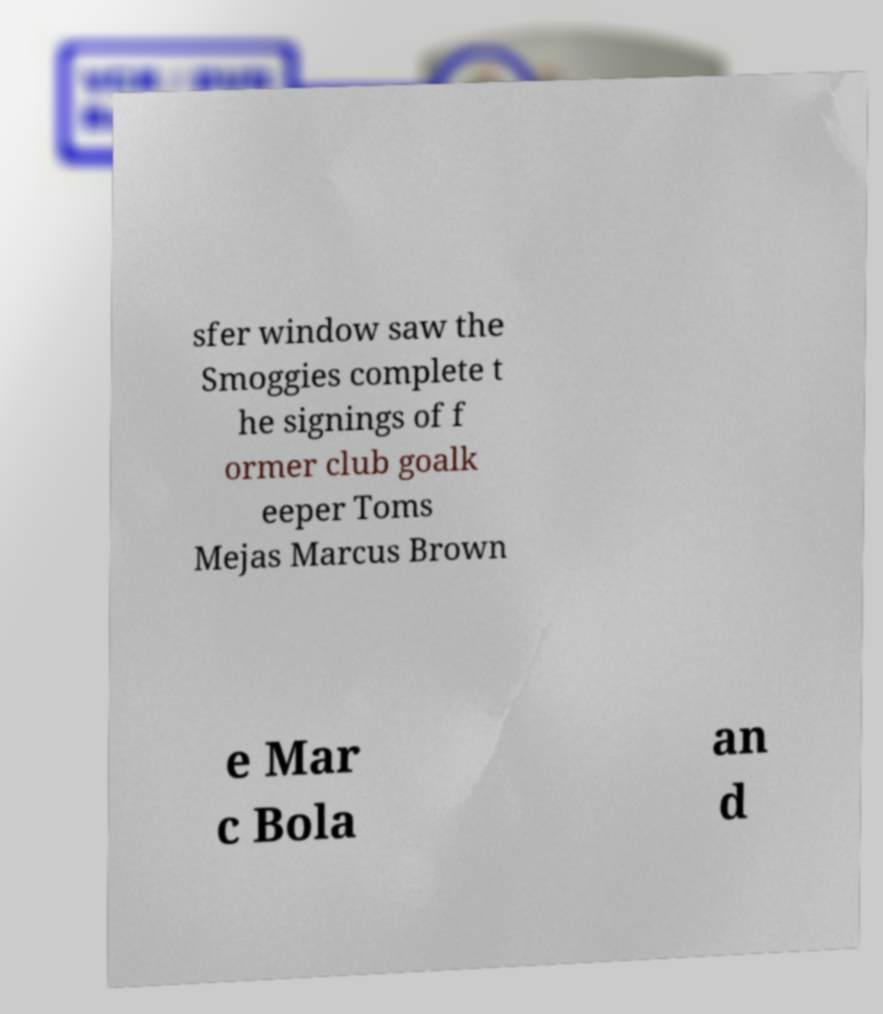There's text embedded in this image that I need extracted. Can you transcribe it verbatim? sfer window saw the Smoggies complete t he signings of f ormer club goalk eeper Toms Mejas Marcus Brown e Mar c Bola an d 